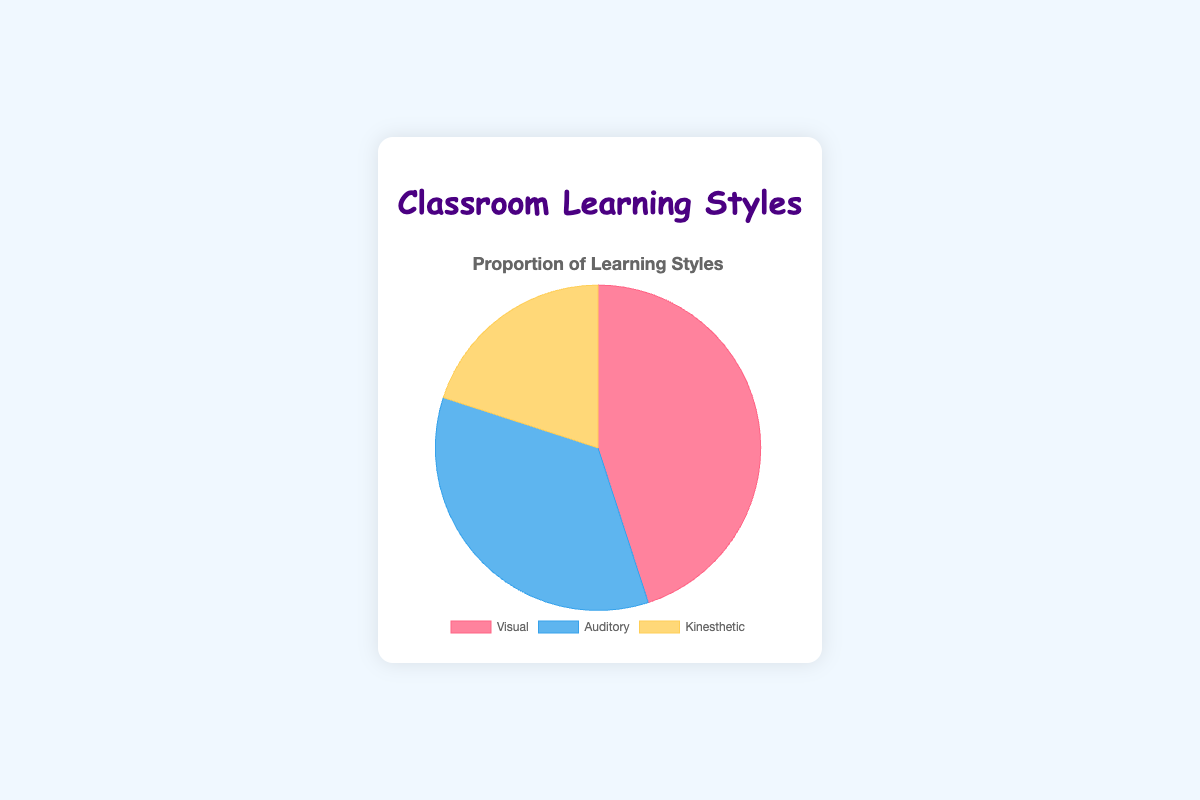What percentage of the classroom prefers auditory learning? Identify the section labeled "Auditory" on the pie chart and read the percentage value.
Answer: 35% What is the difference in percentage between the visual and kinesthetic learners? Find the percentage values for visual and kinesthetic learners (45% and 20% respectively) and subtract the smaller value from the larger one: 45 - 20 = 25.
Answer: 25% Which learning style is the least common in this classroom? Look for the smallest percentage value on the pie chart and identify the corresponding label. In this case, Kinesthetic has the smallest value at 20%.
Answer: Kinesthetic What is the total percentage of visual and auditory learners combined? Add the percentage values for visual and auditory learners: 45 + 35 = 80.
Answer: 80% Compare the proportion of auditory to kinesthetic learners. Which is higher? Compare the percentage values for auditory (35%) and kinesthetic (20%) learners; auditory is higher.
Answer: Auditory What color represents the kinesthetic learners on the pie chart? Identify the section labeled "Kinesthetic" and observe its color; it's represented in yellow.
Answer: Yellow By how much does the proportion of visual learners exceed the combined proportion of auditory and kinesthetic learners? Combine the percentages for auditory and kinesthetic learners (35% + 20% = 55%) and subtract this sum from the proportion of visual learners: 45 - 55. As this subtraction results in a negative number, visual learners do not exceed the combined proportion of auditory and kinesthetic learners. Instead, the combined proportion exceeds visual learners by 10%.
Answer: 10% If you were to group visual and kinesthetic learners together, what percentage would they represent? Add the percentage values for visual and kinesthetic learners: 45 + 20 = 65.
Answer: 65% Which learning style has the largest section on the pie chart, and what is its percentage? Find the largest section on the pie chart and identify its label and percentage. The largest section is Visual at 45%.
Answer: Visual, 45% Estimate the angle of the pie slice representing auditory learners. A pie chart represents a full circle of 360 degrees. The auditory learners' proportion is 35%, so calculate 35% of 360 degrees: 0.35 * 360 = 126 degrees.
Answer: 126 degrees 